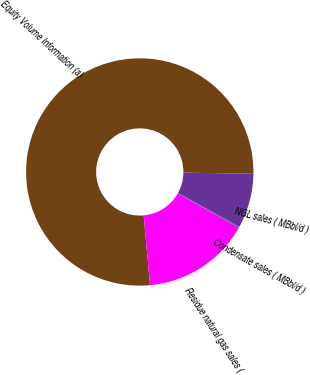Convert chart. <chart><loc_0><loc_0><loc_500><loc_500><pie_chart><fcel>Equity Volume Information (a)<fcel>NGL sales ( MBbl/d )<fcel>Condensate sales ( MBbl/d )<fcel>Residue natural gas sales (<nl><fcel>76.68%<fcel>7.77%<fcel>0.12%<fcel>15.43%<nl></chart> 